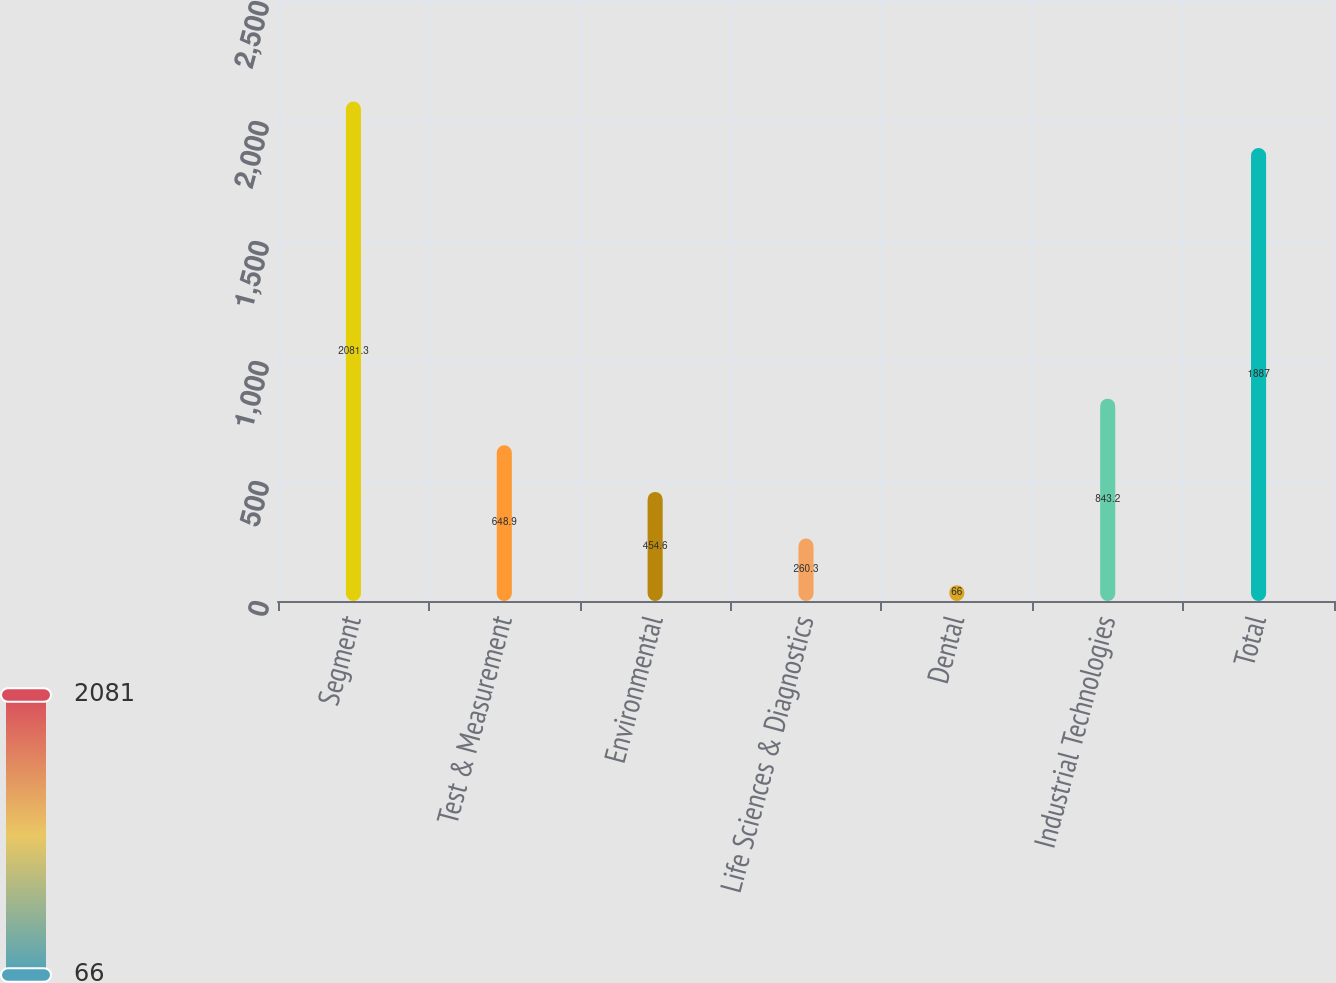<chart> <loc_0><loc_0><loc_500><loc_500><bar_chart><fcel>Segment<fcel>Test & Measurement<fcel>Environmental<fcel>Life Sciences & Diagnostics<fcel>Dental<fcel>Industrial Technologies<fcel>Total<nl><fcel>2081.3<fcel>648.9<fcel>454.6<fcel>260.3<fcel>66<fcel>843.2<fcel>1887<nl></chart> 